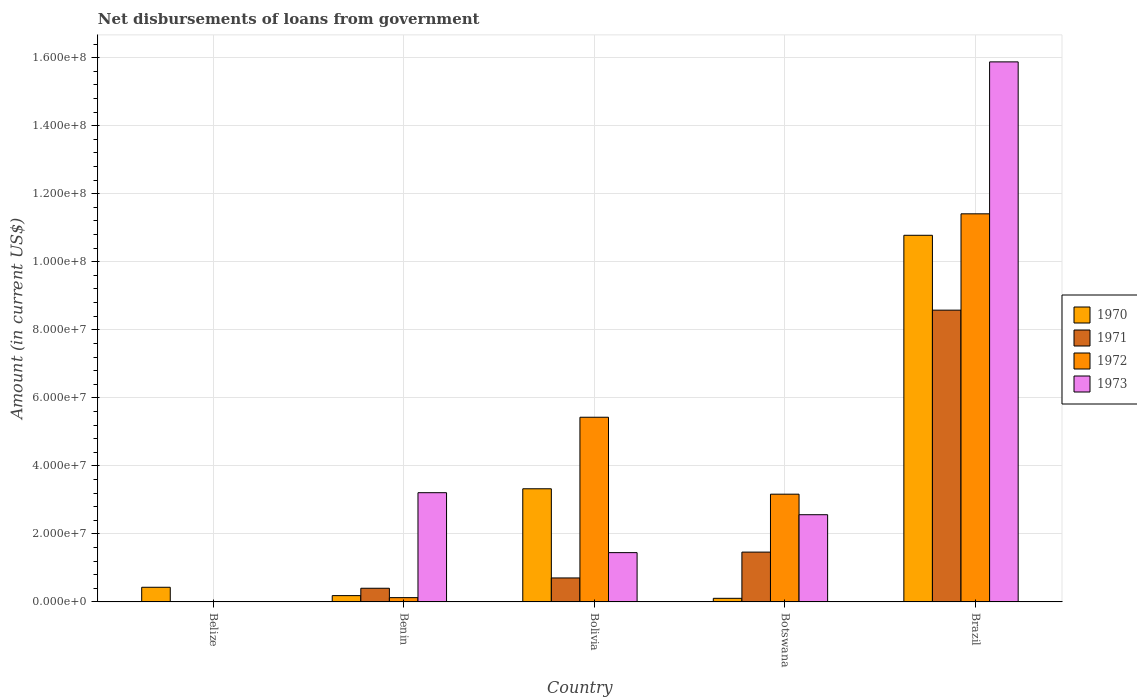How many different coloured bars are there?
Offer a terse response. 4. Are the number of bars on each tick of the X-axis equal?
Your answer should be compact. No. How many bars are there on the 1st tick from the left?
Provide a short and direct response. 1. How many bars are there on the 2nd tick from the right?
Provide a succinct answer. 4. In how many cases, is the number of bars for a given country not equal to the number of legend labels?
Your answer should be very brief. 1. What is the amount of loan disbursed from government in 1971 in Brazil?
Your answer should be compact. 8.58e+07. Across all countries, what is the maximum amount of loan disbursed from government in 1971?
Provide a succinct answer. 8.58e+07. Across all countries, what is the minimum amount of loan disbursed from government in 1973?
Your answer should be compact. 0. What is the total amount of loan disbursed from government in 1972 in the graph?
Ensure brevity in your answer.  2.01e+08. What is the difference between the amount of loan disbursed from government in 1973 in Benin and that in Bolivia?
Ensure brevity in your answer.  1.76e+07. What is the difference between the amount of loan disbursed from government in 1972 in Benin and the amount of loan disbursed from government in 1971 in Bolivia?
Offer a terse response. -5.79e+06. What is the average amount of loan disbursed from government in 1971 per country?
Provide a short and direct response. 2.23e+07. What is the difference between the amount of loan disbursed from government of/in 1973 and amount of loan disbursed from government of/in 1972 in Bolivia?
Provide a short and direct response. -3.98e+07. In how many countries, is the amount of loan disbursed from government in 1973 greater than 60000000 US$?
Your answer should be compact. 1. What is the ratio of the amount of loan disbursed from government in 1971 in Benin to that in Brazil?
Provide a succinct answer. 0.05. Is the amount of loan disbursed from government in 1971 in Bolivia less than that in Botswana?
Keep it short and to the point. Yes. What is the difference between the highest and the second highest amount of loan disbursed from government in 1973?
Offer a very short reply. 1.33e+08. What is the difference between the highest and the lowest amount of loan disbursed from government in 1972?
Keep it short and to the point. 1.14e+08. Is it the case that in every country, the sum of the amount of loan disbursed from government in 1970 and amount of loan disbursed from government in 1973 is greater than the sum of amount of loan disbursed from government in 1972 and amount of loan disbursed from government in 1971?
Offer a very short reply. No. How many bars are there?
Offer a very short reply. 17. Are all the bars in the graph horizontal?
Offer a very short reply. No. How many countries are there in the graph?
Offer a very short reply. 5. Are the values on the major ticks of Y-axis written in scientific E-notation?
Provide a short and direct response. Yes. What is the title of the graph?
Provide a short and direct response. Net disbursements of loans from government. Does "2013" appear as one of the legend labels in the graph?
Your response must be concise. No. What is the label or title of the X-axis?
Give a very brief answer. Country. What is the Amount (in current US$) in 1970 in Belize?
Provide a short and direct response. 4.30e+06. What is the Amount (in current US$) in 1971 in Belize?
Offer a very short reply. 0. What is the Amount (in current US$) of 1970 in Benin?
Keep it short and to the point. 1.85e+06. What is the Amount (in current US$) of 1971 in Benin?
Your answer should be compact. 4.01e+06. What is the Amount (in current US$) in 1972 in Benin?
Ensure brevity in your answer.  1.26e+06. What is the Amount (in current US$) of 1973 in Benin?
Provide a short and direct response. 3.21e+07. What is the Amount (in current US$) of 1970 in Bolivia?
Your answer should be compact. 3.33e+07. What is the Amount (in current US$) in 1971 in Bolivia?
Give a very brief answer. 7.04e+06. What is the Amount (in current US$) of 1972 in Bolivia?
Make the answer very short. 5.43e+07. What is the Amount (in current US$) of 1973 in Bolivia?
Provide a succinct answer. 1.45e+07. What is the Amount (in current US$) in 1970 in Botswana?
Provide a succinct answer. 1.06e+06. What is the Amount (in current US$) in 1971 in Botswana?
Your response must be concise. 1.46e+07. What is the Amount (in current US$) of 1972 in Botswana?
Offer a terse response. 3.17e+07. What is the Amount (in current US$) in 1973 in Botswana?
Keep it short and to the point. 2.56e+07. What is the Amount (in current US$) of 1970 in Brazil?
Make the answer very short. 1.08e+08. What is the Amount (in current US$) of 1971 in Brazil?
Offer a terse response. 8.58e+07. What is the Amount (in current US$) in 1972 in Brazil?
Ensure brevity in your answer.  1.14e+08. What is the Amount (in current US$) of 1973 in Brazil?
Keep it short and to the point. 1.59e+08. Across all countries, what is the maximum Amount (in current US$) of 1970?
Keep it short and to the point. 1.08e+08. Across all countries, what is the maximum Amount (in current US$) in 1971?
Your answer should be very brief. 8.58e+07. Across all countries, what is the maximum Amount (in current US$) in 1972?
Keep it short and to the point. 1.14e+08. Across all countries, what is the maximum Amount (in current US$) of 1973?
Offer a very short reply. 1.59e+08. Across all countries, what is the minimum Amount (in current US$) of 1970?
Ensure brevity in your answer.  1.06e+06. Across all countries, what is the minimum Amount (in current US$) of 1972?
Make the answer very short. 0. Across all countries, what is the minimum Amount (in current US$) in 1973?
Your answer should be compact. 0. What is the total Amount (in current US$) in 1970 in the graph?
Give a very brief answer. 1.48e+08. What is the total Amount (in current US$) in 1971 in the graph?
Provide a short and direct response. 1.11e+08. What is the total Amount (in current US$) in 1972 in the graph?
Your answer should be very brief. 2.01e+08. What is the total Amount (in current US$) of 1973 in the graph?
Offer a terse response. 2.31e+08. What is the difference between the Amount (in current US$) of 1970 in Belize and that in Benin?
Your answer should be compact. 2.45e+06. What is the difference between the Amount (in current US$) of 1970 in Belize and that in Bolivia?
Keep it short and to the point. -2.90e+07. What is the difference between the Amount (in current US$) in 1970 in Belize and that in Botswana?
Your answer should be very brief. 3.24e+06. What is the difference between the Amount (in current US$) of 1970 in Belize and that in Brazil?
Offer a very short reply. -1.03e+08. What is the difference between the Amount (in current US$) in 1970 in Benin and that in Bolivia?
Your answer should be compact. -3.14e+07. What is the difference between the Amount (in current US$) of 1971 in Benin and that in Bolivia?
Offer a terse response. -3.03e+06. What is the difference between the Amount (in current US$) in 1972 in Benin and that in Bolivia?
Provide a succinct answer. -5.30e+07. What is the difference between the Amount (in current US$) of 1973 in Benin and that in Bolivia?
Provide a short and direct response. 1.76e+07. What is the difference between the Amount (in current US$) in 1970 in Benin and that in Botswana?
Provide a succinct answer. 7.92e+05. What is the difference between the Amount (in current US$) in 1971 in Benin and that in Botswana?
Make the answer very short. -1.06e+07. What is the difference between the Amount (in current US$) of 1972 in Benin and that in Botswana?
Offer a very short reply. -3.04e+07. What is the difference between the Amount (in current US$) in 1973 in Benin and that in Botswana?
Your answer should be very brief. 6.47e+06. What is the difference between the Amount (in current US$) in 1970 in Benin and that in Brazil?
Offer a very short reply. -1.06e+08. What is the difference between the Amount (in current US$) in 1971 in Benin and that in Brazil?
Make the answer very short. -8.18e+07. What is the difference between the Amount (in current US$) of 1972 in Benin and that in Brazil?
Your response must be concise. -1.13e+08. What is the difference between the Amount (in current US$) in 1973 in Benin and that in Brazil?
Your response must be concise. -1.27e+08. What is the difference between the Amount (in current US$) in 1970 in Bolivia and that in Botswana?
Provide a succinct answer. 3.22e+07. What is the difference between the Amount (in current US$) in 1971 in Bolivia and that in Botswana?
Offer a terse response. -7.60e+06. What is the difference between the Amount (in current US$) of 1972 in Bolivia and that in Botswana?
Provide a succinct answer. 2.26e+07. What is the difference between the Amount (in current US$) of 1973 in Bolivia and that in Botswana?
Give a very brief answer. -1.11e+07. What is the difference between the Amount (in current US$) in 1970 in Bolivia and that in Brazil?
Your answer should be very brief. -7.45e+07. What is the difference between the Amount (in current US$) in 1971 in Bolivia and that in Brazil?
Keep it short and to the point. -7.87e+07. What is the difference between the Amount (in current US$) of 1972 in Bolivia and that in Brazil?
Keep it short and to the point. -5.98e+07. What is the difference between the Amount (in current US$) of 1973 in Bolivia and that in Brazil?
Your response must be concise. -1.44e+08. What is the difference between the Amount (in current US$) of 1970 in Botswana and that in Brazil?
Offer a terse response. -1.07e+08. What is the difference between the Amount (in current US$) in 1971 in Botswana and that in Brazil?
Give a very brief answer. -7.11e+07. What is the difference between the Amount (in current US$) of 1972 in Botswana and that in Brazil?
Your answer should be compact. -8.24e+07. What is the difference between the Amount (in current US$) in 1973 in Botswana and that in Brazil?
Your answer should be compact. -1.33e+08. What is the difference between the Amount (in current US$) of 1970 in Belize and the Amount (in current US$) of 1971 in Benin?
Provide a succinct answer. 2.89e+05. What is the difference between the Amount (in current US$) in 1970 in Belize and the Amount (in current US$) in 1972 in Benin?
Ensure brevity in your answer.  3.05e+06. What is the difference between the Amount (in current US$) of 1970 in Belize and the Amount (in current US$) of 1973 in Benin?
Provide a succinct answer. -2.78e+07. What is the difference between the Amount (in current US$) of 1970 in Belize and the Amount (in current US$) of 1971 in Bolivia?
Keep it short and to the point. -2.74e+06. What is the difference between the Amount (in current US$) of 1970 in Belize and the Amount (in current US$) of 1972 in Bolivia?
Keep it short and to the point. -5.00e+07. What is the difference between the Amount (in current US$) of 1970 in Belize and the Amount (in current US$) of 1973 in Bolivia?
Your answer should be very brief. -1.02e+07. What is the difference between the Amount (in current US$) in 1970 in Belize and the Amount (in current US$) in 1971 in Botswana?
Your answer should be compact. -1.03e+07. What is the difference between the Amount (in current US$) of 1970 in Belize and the Amount (in current US$) of 1972 in Botswana?
Make the answer very short. -2.74e+07. What is the difference between the Amount (in current US$) of 1970 in Belize and the Amount (in current US$) of 1973 in Botswana?
Your response must be concise. -2.13e+07. What is the difference between the Amount (in current US$) in 1970 in Belize and the Amount (in current US$) in 1971 in Brazil?
Your response must be concise. -8.15e+07. What is the difference between the Amount (in current US$) of 1970 in Belize and the Amount (in current US$) of 1972 in Brazil?
Provide a succinct answer. -1.10e+08. What is the difference between the Amount (in current US$) of 1970 in Belize and the Amount (in current US$) of 1973 in Brazil?
Keep it short and to the point. -1.54e+08. What is the difference between the Amount (in current US$) in 1970 in Benin and the Amount (in current US$) in 1971 in Bolivia?
Provide a short and direct response. -5.19e+06. What is the difference between the Amount (in current US$) of 1970 in Benin and the Amount (in current US$) of 1972 in Bolivia?
Your answer should be very brief. -5.24e+07. What is the difference between the Amount (in current US$) in 1970 in Benin and the Amount (in current US$) in 1973 in Bolivia?
Offer a very short reply. -1.26e+07. What is the difference between the Amount (in current US$) of 1971 in Benin and the Amount (in current US$) of 1972 in Bolivia?
Your response must be concise. -5.03e+07. What is the difference between the Amount (in current US$) in 1971 in Benin and the Amount (in current US$) in 1973 in Bolivia?
Offer a terse response. -1.05e+07. What is the difference between the Amount (in current US$) in 1972 in Benin and the Amount (in current US$) in 1973 in Bolivia?
Ensure brevity in your answer.  -1.32e+07. What is the difference between the Amount (in current US$) of 1970 in Benin and the Amount (in current US$) of 1971 in Botswana?
Your answer should be compact. -1.28e+07. What is the difference between the Amount (in current US$) in 1970 in Benin and the Amount (in current US$) in 1972 in Botswana?
Your answer should be very brief. -2.98e+07. What is the difference between the Amount (in current US$) of 1970 in Benin and the Amount (in current US$) of 1973 in Botswana?
Make the answer very short. -2.38e+07. What is the difference between the Amount (in current US$) in 1971 in Benin and the Amount (in current US$) in 1972 in Botswana?
Make the answer very short. -2.77e+07. What is the difference between the Amount (in current US$) of 1971 in Benin and the Amount (in current US$) of 1973 in Botswana?
Provide a short and direct response. -2.16e+07. What is the difference between the Amount (in current US$) in 1972 in Benin and the Amount (in current US$) in 1973 in Botswana?
Offer a very short reply. -2.44e+07. What is the difference between the Amount (in current US$) of 1970 in Benin and the Amount (in current US$) of 1971 in Brazil?
Your answer should be compact. -8.39e+07. What is the difference between the Amount (in current US$) in 1970 in Benin and the Amount (in current US$) in 1972 in Brazil?
Give a very brief answer. -1.12e+08. What is the difference between the Amount (in current US$) of 1970 in Benin and the Amount (in current US$) of 1973 in Brazil?
Offer a very short reply. -1.57e+08. What is the difference between the Amount (in current US$) in 1971 in Benin and the Amount (in current US$) in 1972 in Brazil?
Give a very brief answer. -1.10e+08. What is the difference between the Amount (in current US$) of 1971 in Benin and the Amount (in current US$) of 1973 in Brazil?
Your answer should be very brief. -1.55e+08. What is the difference between the Amount (in current US$) of 1972 in Benin and the Amount (in current US$) of 1973 in Brazil?
Offer a terse response. -1.58e+08. What is the difference between the Amount (in current US$) in 1970 in Bolivia and the Amount (in current US$) in 1971 in Botswana?
Make the answer very short. 1.86e+07. What is the difference between the Amount (in current US$) of 1970 in Bolivia and the Amount (in current US$) of 1972 in Botswana?
Keep it short and to the point. 1.59e+06. What is the difference between the Amount (in current US$) in 1970 in Bolivia and the Amount (in current US$) in 1973 in Botswana?
Provide a short and direct response. 7.63e+06. What is the difference between the Amount (in current US$) of 1971 in Bolivia and the Amount (in current US$) of 1972 in Botswana?
Make the answer very short. -2.46e+07. What is the difference between the Amount (in current US$) of 1971 in Bolivia and the Amount (in current US$) of 1973 in Botswana?
Make the answer very short. -1.86e+07. What is the difference between the Amount (in current US$) of 1972 in Bolivia and the Amount (in current US$) of 1973 in Botswana?
Provide a succinct answer. 2.87e+07. What is the difference between the Amount (in current US$) in 1970 in Bolivia and the Amount (in current US$) in 1971 in Brazil?
Ensure brevity in your answer.  -5.25e+07. What is the difference between the Amount (in current US$) in 1970 in Bolivia and the Amount (in current US$) in 1972 in Brazil?
Give a very brief answer. -8.08e+07. What is the difference between the Amount (in current US$) of 1970 in Bolivia and the Amount (in current US$) of 1973 in Brazil?
Offer a very short reply. -1.26e+08. What is the difference between the Amount (in current US$) of 1971 in Bolivia and the Amount (in current US$) of 1972 in Brazil?
Your response must be concise. -1.07e+08. What is the difference between the Amount (in current US$) of 1971 in Bolivia and the Amount (in current US$) of 1973 in Brazil?
Keep it short and to the point. -1.52e+08. What is the difference between the Amount (in current US$) of 1972 in Bolivia and the Amount (in current US$) of 1973 in Brazil?
Your answer should be compact. -1.04e+08. What is the difference between the Amount (in current US$) in 1970 in Botswana and the Amount (in current US$) in 1971 in Brazil?
Your response must be concise. -8.47e+07. What is the difference between the Amount (in current US$) of 1970 in Botswana and the Amount (in current US$) of 1972 in Brazil?
Provide a short and direct response. -1.13e+08. What is the difference between the Amount (in current US$) of 1970 in Botswana and the Amount (in current US$) of 1973 in Brazil?
Give a very brief answer. -1.58e+08. What is the difference between the Amount (in current US$) in 1971 in Botswana and the Amount (in current US$) in 1972 in Brazil?
Give a very brief answer. -9.95e+07. What is the difference between the Amount (in current US$) of 1971 in Botswana and the Amount (in current US$) of 1973 in Brazil?
Offer a terse response. -1.44e+08. What is the difference between the Amount (in current US$) in 1972 in Botswana and the Amount (in current US$) in 1973 in Brazil?
Provide a succinct answer. -1.27e+08. What is the average Amount (in current US$) of 1970 per country?
Keep it short and to the point. 2.97e+07. What is the average Amount (in current US$) in 1971 per country?
Your response must be concise. 2.23e+07. What is the average Amount (in current US$) of 1972 per country?
Your response must be concise. 4.03e+07. What is the average Amount (in current US$) of 1973 per country?
Your answer should be compact. 4.62e+07. What is the difference between the Amount (in current US$) in 1970 and Amount (in current US$) in 1971 in Benin?
Your answer should be compact. -2.16e+06. What is the difference between the Amount (in current US$) of 1970 and Amount (in current US$) of 1972 in Benin?
Provide a short and direct response. 5.94e+05. What is the difference between the Amount (in current US$) of 1970 and Amount (in current US$) of 1973 in Benin?
Provide a succinct answer. -3.03e+07. What is the difference between the Amount (in current US$) in 1971 and Amount (in current US$) in 1972 in Benin?
Make the answer very short. 2.76e+06. What is the difference between the Amount (in current US$) in 1971 and Amount (in current US$) in 1973 in Benin?
Your response must be concise. -2.81e+07. What is the difference between the Amount (in current US$) in 1972 and Amount (in current US$) in 1973 in Benin?
Keep it short and to the point. -3.09e+07. What is the difference between the Amount (in current US$) of 1970 and Amount (in current US$) of 1971 in Bolivia?
Your answer should be very brief. 2.62e+07. What is the difference between the Amount (in current US$) of 1970 and Amount (in current US$) of 1972 in Bolivia?
Ensure brevity in your answer.  -2.10e+07. What is the difference between the Amount (in current US$) in 1970 and Amount (in current US$) in 1973 in Bolivia?
Make the answer very short. 1.88e+07. What is the difference between the Amount (in current US$) in 1971 and Amount (in current US$) in 1972 in Bolivia?
Ensure brevity in your answer.  -4.72e+07. What is the difference between the Amount (in current US$) of 1971 and Amount (in current US$) of 1973 in Bolivia?
Make the answer very short. -7.44e+06. What is the difference between the Amount (in current US$) of 1972 and Amount (in current US$) of 1973 in Bolivia?
Your answer should be very brief. 3.98e+07. What is the difference between the Amount (in current US$) in 1970 and Amount (in current US$) in 1971 in Botswana?
Provide a short and direct response. -1.36e+07. What is the difference between the Amount (in current US$) of 1970 and Amount (in current US$) of 1972 in Botswana?
Give a very brief answer. -3.06e+07. What is the difference between the Amount (in current US$) of 1970 and Amount (in current US$) of 1973 in Botswana?
Ensure brevity in your answer.  -2.46e+07. What is the difference between the Amount (in current US$) in 1971 and Amount (in current US$) in 1972 in Botswana?
Provide a short and direct response. -1.70e+07. What is the difference between the Amount (in current US$) of 1971 and Amount (in current US$) of 1973 in Botswana?
Keep it short and to the point. -1.10e+07. What is the difference between the Amount (in current US$) of 1972 and Amount (in current US$) of 1973 in Botswana?
Offer a terse response. 6.03e+06. What is the difference between the Amount (in current US$) of 1970 and Amount (in current US$) of 1971 in Brazil?
Offer a terse response. 2.20e+07. What is the difference between the Amount (in current US$) in 1970 and Amount (in current US$) in 1972 in Brazil?
Offer a very short reply. -6.31e+06. What is the difference between the Amount (in current US$) in 1970 and Amount (in current US$) in 1973 in Brazil?
Your response must be concise. -5.10e+07. What is the difference between the Amount (in current US$) of 1971 and Amount (in current US$) of 1972 in Brazil?
Provide a succinct answer. -2.83e+07. What is the difference between the Amount (in current US$) in 1971 and Amount (in current US$) in 1973 in Brazil?
Provide a short and direct response. -7.30e+07. What is the difference between the Amount (in current US$) in 1972 and Amount (in current US$) in 1973 in Brazil?
Your answer should be compact. -4.47e+07. What is the ratio of the Amount (in current US$) in 1970 in Belize to that in Benin?
Your answer should be compact. 2.33. What is the ratio of the Amount (in current US$) in 1970 in Belize to that in Bolivia?
Keep it short and to the point. 0.13. What is the ratio of the Amount (in current US$) in 1970 in Belize to that in Botswana?
Offer a terse response. 4.07. What is the ratio of the Amount (in current US$) in 1970 in Belize to that in Brazil?
Your answer should be compact. 0.04. What is the ratio of the Amount (in current US$) in 1970 in Benin to that in Bolivia?
Give a very brief answer. 0.06. What is the ratio of the Amount (in current US$) of 1971 in Benin to that in Bolivia?
Your answer should be very brief. 0.57. What is the ratio of the Amount (in current US$) in 1972 in Benin to that in Bolivia?
Provide a short and direct response. 0.02. What is the ratio of the Amount (in current US$) in 1973 in Benin to that in Bolivia?
Ensure brevity in your answer.  2.22. What is the ratio of the Amount (in current US$) in 1970 in Benin to that in Botswana?
Provide a succinct answer. 1.75. What is the ratio of the Amount (in current US$) of 1971 in Benin to that in Botswana?
Make the answer very short. 0.27. What is the ratio of the Amount (in current US$) of 1972 in Benin to that in Botswana?
Offer a very short reply. 0.04. What is the ratio of the Amount (in current US$) in 1973 in Benin to that in Botswana?
Provide a short and direct response. 1.25. What is the ratio of the Amount (in current US$) in 1970 in Benin to that in Brazil?
Provide a succinct answer. 0.02. What is the ratio of the Amount (in current US$) in 1971 in Benin to that in Brazil?
Offer a very short reply. 0.05. What is the ratio of the Amount (in current US$) of 1972 in Benin to that in Brazil?
Offer a very short reply. 0.01. What is the ratio of the Amount (in current US$) of 1973 in Benin to that in Brazil?
Keep it short and to the point. 0.2. What is the ratio of the Amount (in current US$) of 1970 in Bolivia to that in Botswana?
Offer a terse response. 31.47. What is the ratio of the Amount (in current US$) of 1971 in Bolivia to that in Botswana?
Keep it short and to the point. 0.48. What is the ratio of the Amount (in current US$) in 1972 in Bolivia to that in Botswana?
Provide a short and direct response. 1.71. What is the ratio of the Amount (in current US$) of 1973 in Bolivia to that in Botswana?
Your answer should be very brief. 0.57. What is the ratio of the Amount (in current US$) of 1970 in Bolivia to that in Brazil?
Give a very brief answer. 0.31. What is the ratio of the Amount (in current US$) in 1971 in Bolivia to that in Brazil?
Offer a terse response. 0.08. What is the ratio of the Amount (in current US$) of 1972 in Bolivia to that in Brazil?
Offer a very short reply. 0.48. What is the ratio of the Amount (in current US$) of 1973 in Bolivia to that in Brazil?
Give a very brief answer. 0.09. What is the ratio of the Amount (in current US$) of 1970 in Botswana to that in Brazil?
Your response must be concise. 0.01. What is the ratio of the Amount (in current US$) in 1971 in Botswana to that in Brazil?
Your answer should be very brief. 0.17. What is the ratio of the Amount (in current US$) of 1972 in Botswana to that in Brazil?
Your response must be concise. 0.28. What is the ratio of the Amount (in current US$) of 1973 in Botswana to that in Brazil?
Offer a terse response. 0.16. What is the difference between the highest and the second highest Amount (in current US$) in 1970?
Keep it short and to the point. 7.45e+07. What is the difference between the highest and the second highest Amount (in current US$) in 1971?
Your answer should be very brief. 7.11e+07. What is the difference between the highest and the second highest Amount (in current US$) in 1972?
Provide a short and direct response. 5.98e+07. What is the difference between the highest and the second highest Amount (in current US$) in 1973?
Ensure brevity in your answer.  1.27e+08. What is the difference between the highest and the lowest Amount (in current US$) of 1970?
Give a very brief answer. 1.07e+08. What is the difference between the highest and the lowest Amount (in current US$) of 1971?
Make the answer very short. 8.58e+07. What is the difference between the highest and the lowest Amount (in current US$) of 1972?
Ensure brevity in your answer.  1.14e+08. What is the difference between the highest and the lowest Amount (in current US$) of 1973?
Provide a succinct answer. 1.59e+08. 